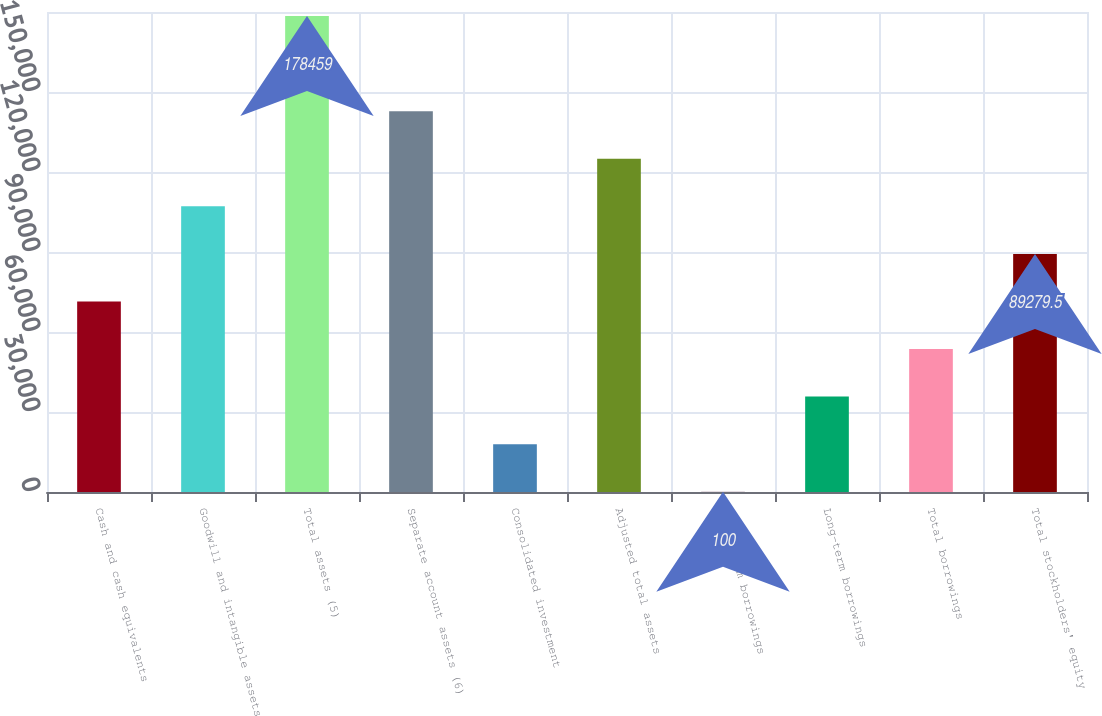Convert chart to OTSL. <chart><loc_0><loc_0><loc_500><loc_500><bar_chart><fcel>Cash and cash equivalents<fcel>Goodwill and intangible assets<fcel>Total assets (5)<fcel>Separate account assets (6)<fcel>Consolidated investment<fcel>Adjusted total assets<fcel>Short-term borrowings<fcel>Long-term borrowings<fcel>Total borrowings<fcel>Total stockholders' equity<nl><fcel>71443.6<fcel>107115<fcel>178459<fcel>142787<fcel>17935.9<fcel>124951<fcel>100<fcel>35771.8<fcel>53607.7<fcel>89279.5<nl></chart> 